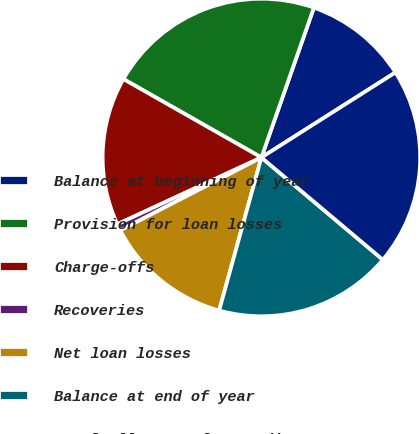Convert chart. <chart><loc_0><loc_0><loc_500><loc_500><pie_chart><fcel>Balance at beginning of year<fcel>Provision for loan losses<fcel>Charge-offs<fcel>Recoveries<fcel>Net loan losses<fcel>Balance at end of year<fcel>Total allowance for credit<nl><fcel>10.64%<fcel>22.14%<fcel>15.13%<fcel>0.68%<fcel>13.13%<fcel>18.15%<fcel>20.14%<nl></chart> 